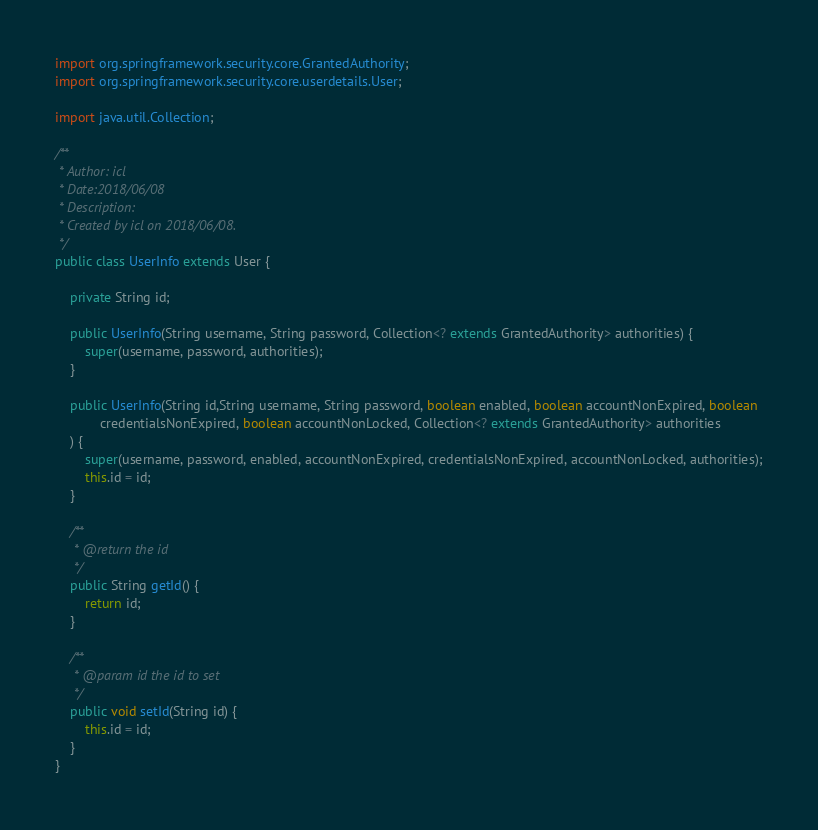<code> <loc_0><loc_0><loc_500><loc_500><_Java_>
import org.springframework.security.core.GrantedAuthority;
import org.springframework.security.core.userdetails.User;

import java.util.Collection;

/**
 * Author: icl
 * Date:2018/06/08
 * Description:
 * Created by icl on 2018/06/08.
 */
public class UserInfo extends User {

    private String id;

    public UserInfo(String username, String password, Collection<? extends GrantedAuthority> authorities) {
        super(username, password, authorities);
    }

    public UserInfo(String id,String username, String password, boolean enabled, boolean accountNonExpired, boolean
            credentialsNonExpired, boolean accountNonLocked, Collection<? extends GrantedAuthority> authorities
    ) {
        super(username, password, enabled, accountNonExpired, credentialsNonExpired, accountNonLocked, authorities);
        this.id = id;
    }

    /**
     * @return the id
     */
    public String getId() {
        return id;
    }

    /**
     * @param id the id to set
     */
    public void setId(String id) {
        this.id = id;
    }
}
</code> 